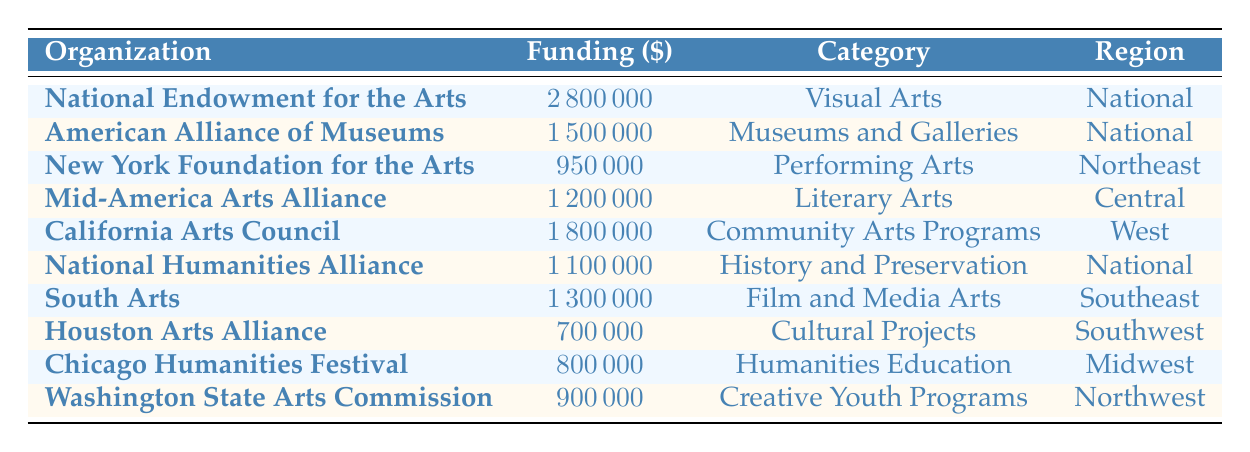What is the total funding amount allocated to National organizations? The organizations listed in the National region are the National Endowment for the Arts, American Alliance of Museums, National Humanities Alliance. Their funding amounts are 2,800,000 + 1,500,000 + 1,100,000 = 5,400,000.
Answer: 5,400,000 Which organization received the highest funding in 2022? The National Endowment for the Arts received the highest funding of 2,800,000, as it is the largest value in the Funding Amount column.
Answer: National Endowment for the Arts Is the funding for the California Arts Council greater than that for the Houston Arts Alliance? The California Arts Council received 1,800,000 while the Houston Arts Alliance received 700,000, thus 1,800,000 is greater than 700,000.
Answer: Yes What is the average funding for organizations in the Southeast region? The organization from the Southeast region is South Arts with a funding amount of 1,300,000. As there is only one organization, the average funding is the same: 1,300,000/1 = 1,300,000.
Answer: 1,300,000 How much more funding did the California Arts Council receive than the New York Foundation for the Arts? The California Arts Council received 1,800,000 and the New York Foundation for the Arts received 950,000. The difference is calculated as 1,800,000 - 950,000 = 850,000.
Answer: 850,000 Which two categories received a funding amount of more than 1,000,000? Reviewing the Funding Amounts, National Endowment for the Arts (Visual Arts) 2,800,000, American Alliance of Museums (Museums and Galleries) 1,500,000, California Arts Council (Community Arts Programs) 1,800,000, and South Arts (Film and Media Arts) 1,300,000 all exceed 1,000,000. Thus, there are four categories, not two.
Answer: Four categories Did any organization in the Midwest receive funding less than 800,000? The Chicago Humanities Festival from the Midwest received 800,000, which is not less than 800,000. Hence there is no organization in the Midwest with less than this amount.
Answer: No What is the total funding for the Performing Arts and Literary Arts categories? The New York Foundation for the Arts (Performing Arts) received 950,000 and Mid-America Arts Alliance (Literary Arts) received 1,200,000. The total funding is calculated as 950,000 + 1,200,000 = 2,150,000.
Answer: 2,150,000 Which region received the least funding overall? The organization with the least funding is the Houston Arts Alliance from the Southwest region, which received 700,000. Therefore, it indicates that the Southwest region had the least overall funding.
Answer: Southwest 